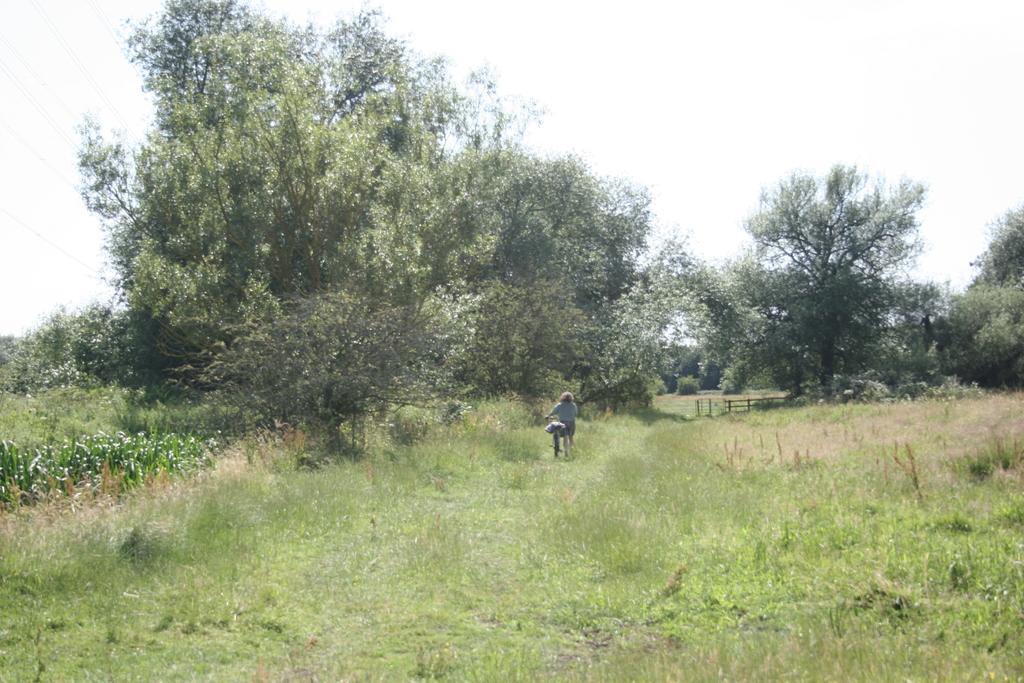Describe this image in one or two sentences. In this picture we can see a woman holding a bicycle and an object is visible on this bicycle. Some grass is visible on the ground. Few trees are seen in the background. 